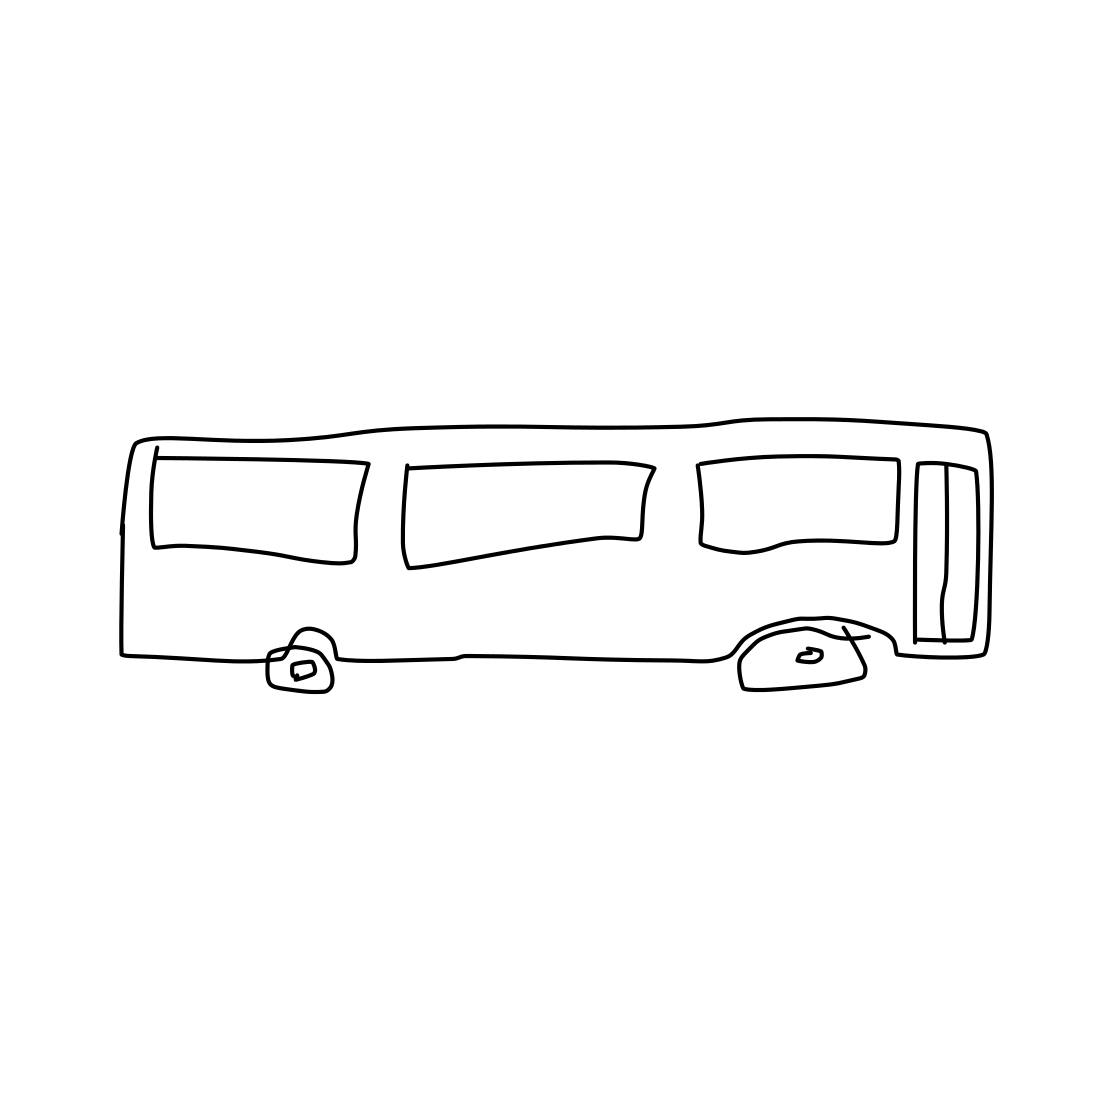Is there a sketchy mushroom in the picture? No 